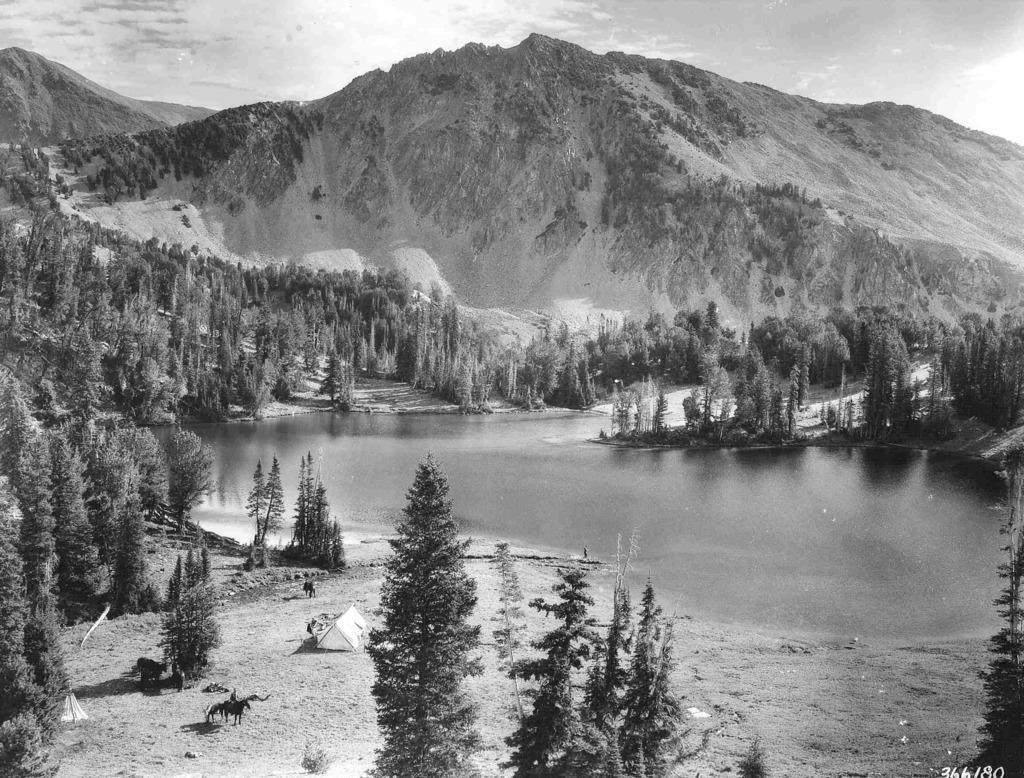What is the color scheme of the image? The image is black and white. What type of landscape can be seen in the image? There are hills and trees in the image. What type of shelter is present in the image? There is a tent in the image. What type of terrain is visible in the image? There is sand in the image. What natural element is present in the image? There is water in the image. What part of the sky is visible in the image? The sky is visible in the image. Where are the numbers located in the image? The numbers are in the bottom right corner of the image. How many family members are sitting on the cushion in the image? There is no cushion or family members present in the image. What type of pest can be seen crawling on the tent in the image? There are no pests visible in the image; the tent appears to be in good condition. 